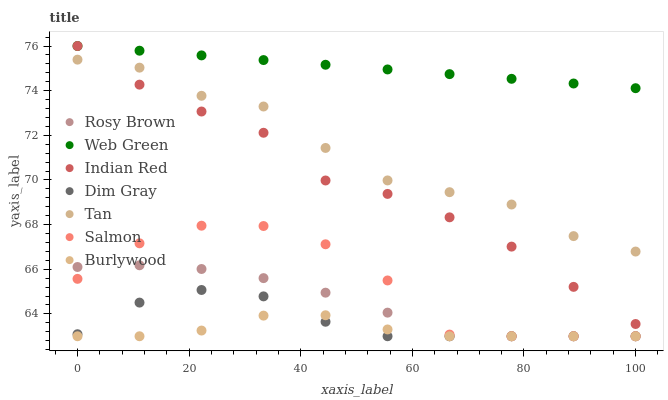Does Burlywood have the minimum area under the curve?
Answer yes or no. Yes. Does Web Green have the maximum area under the curve?
Answer yes or no. Yes. Does Rosy Brown have the minimum area under the curve?
Answer yes or no. No. Does Rosy Brown have the maximum area under the curve?
Answer yes or no. No. Is Web Green the smoothest?
Answer yes or no. Yes. Is Salmon the roughest?
Answer yes or no. Yes. Is Burlywood the smoothest?
Answer yes or no. No. Is Burlywood the roughest?
Answer yes or no. No. Does Dim Gray have the lowest value?
Answer yes or no. Yes. Does Web Green have the lowest value?
Answer yes or no. No. Does Indian Red have the highest value?
Answer yes or no. Yes. Does Rosy Brown have the highest value?
Answer yes or no. No. Is Burlywood less than Tan?
Answer yes or no. Yes. Is Web Green greater than Tan?
Answer yes or no. Yes. Does Dim Gray intersect Rosy Brown?
Answer yes or no. Yes. Is Dim Gray less than Rosy Brown?
Answer yes or no. No. Is Dim Gray greater than Rosy Brown?
Answer yes or no. No. Does Burlywood intersect Tan?
Answer yes or no. No. 